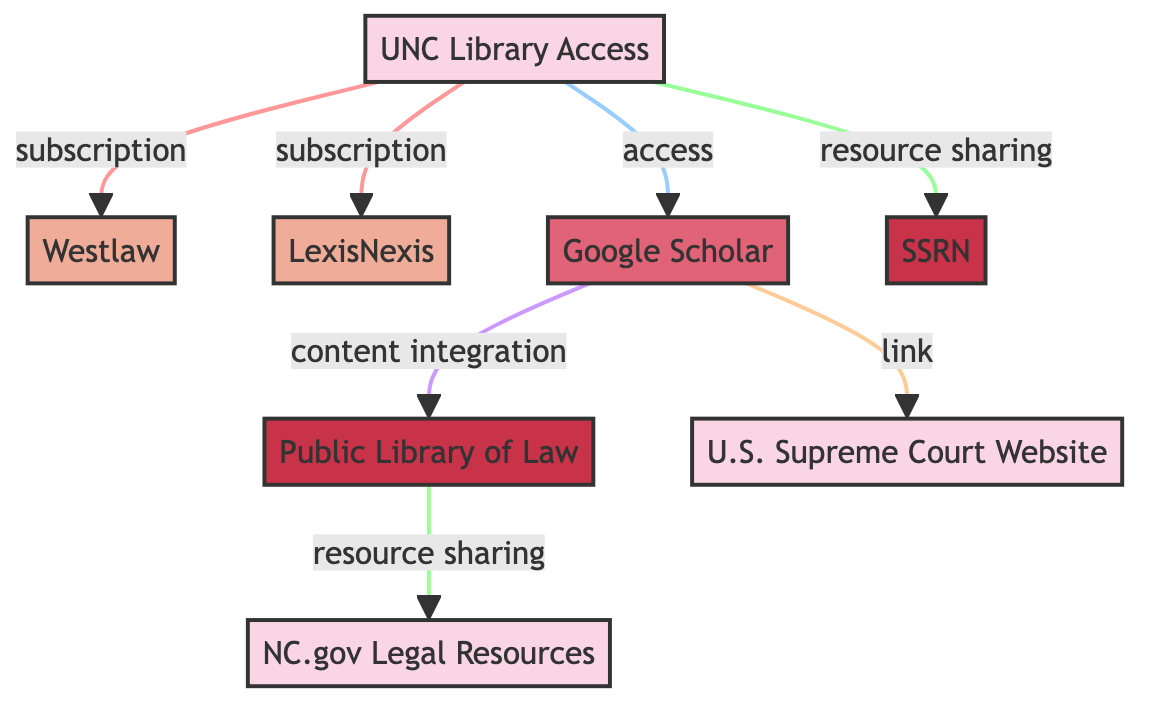What is the total number of nodes in the diagram? By counting the nodes listed in the data, there are eight distinct nodes present, including specific resources, databases, and portals.
Answer: Eight Which resource provides access to Westlaw? The diagram shows a direct link from UNC Library Access to Westlaw, indicating that UNC Library provides this access.
Answer: UNC Library Access How many types of databases are included in the diagram? The diagram identifies two databases, Westlaw and LexisNexis, which are categorized as databases.
Answer: Two What type of relationship exists between Google Scholar and the U.S. Supreme Court Website? The edge between Google Scholar and the U.S. Supreme Court Website is labeled as a link, signifying a direct relationship of connectivity.
Answer: Link Does the UNC Library provide access to LexisNexis? The edge from UNC Library Access to LexisNexis, marked as a subscription, confirms that this access is indeed provided.
Answer: Yes Which repository is integrated into Google Scholar? The relationship shows that Google Scholar integrates content from the Public Library of Law, indicating that this repository contributes legal materials.
Answer: Public Library of Law What resource does the Public Library of Law provide links to? The edge from the Public Library of Law to NC.gov Legal Resources indicates that it shares links to North Carolina’s legal resources.
Answer: NC.gov Legal Resources Which resource integrates with Google Scholar? The edge indicates that Google Scholar integrates content from the Public Library of Law, demonstrating a relationship of content inclusion.
Answer: Public Library of Law 